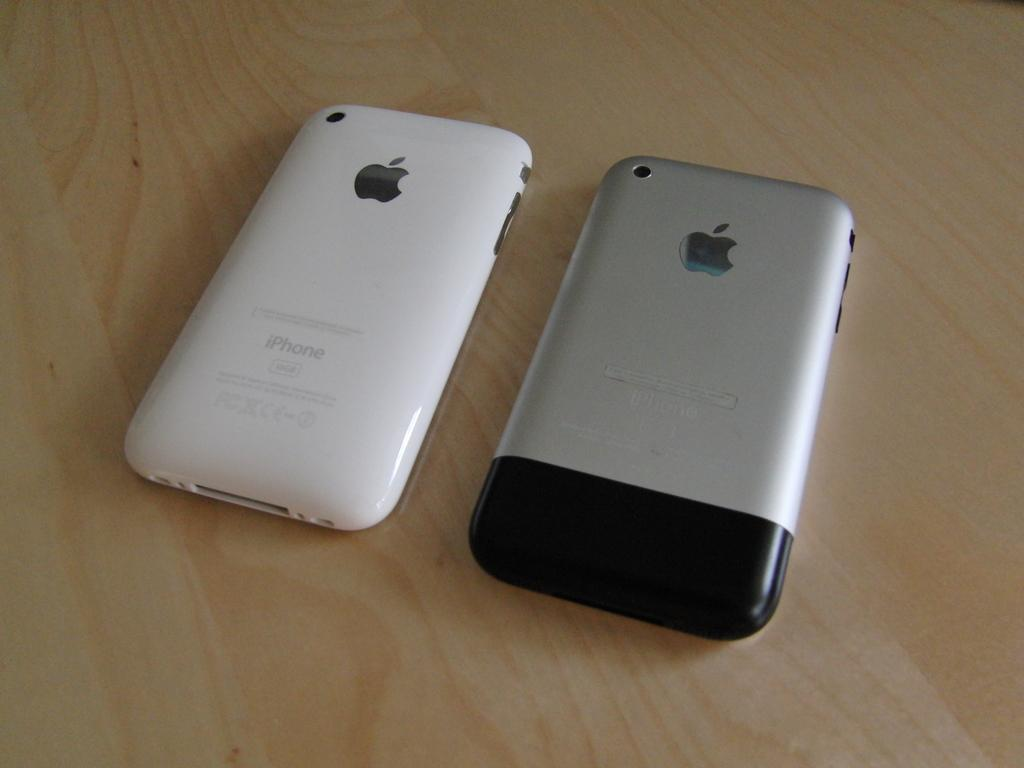<image>
Describe the image concisely. Two iPhone's are face down on the wooden surface 